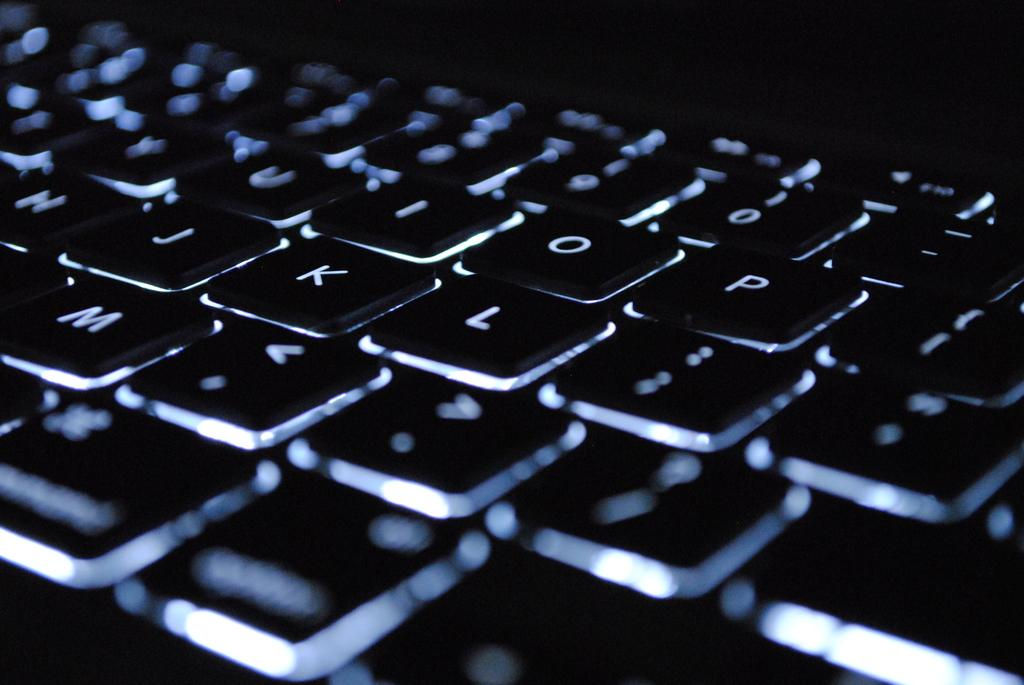<image>
Offer a succinct explanation of the picture presented. a keyboard displaying different letters like p o l and numbers 